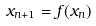<formula> <loc_0><loc_0><loc_500><loc_500>x _ { n + 1 } = f ( x _ { n } )</formula> 